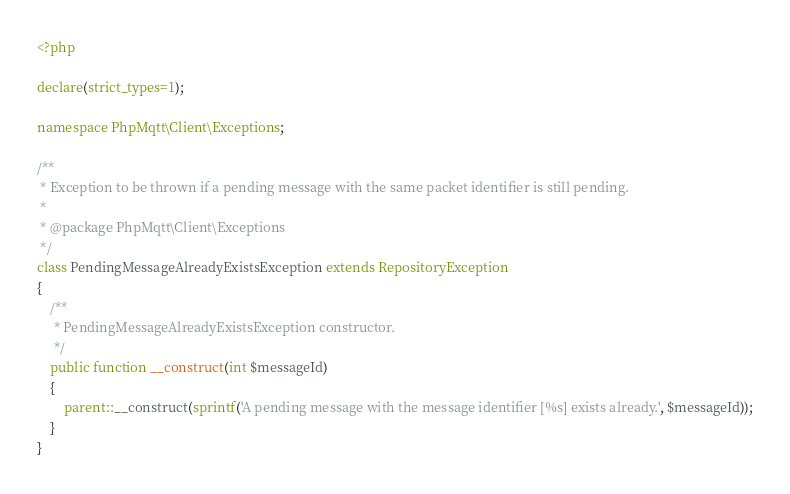Convert code to text. <code><loc_0><loc_0><loc_500><loc_500><_PHP_><?php

declare(strict_types=1);

namespace PhpMqtt\Client\Exceptions;

/**
 * Exception to be thrown if a pending message with the same packet identifier is still pending.
 *
 * @package PhpMqtt\Client\Exceptions
 */
class PendingMessageAlreadyExistsException extends RepositoryException
{
    /**
     * PendingMessageAlreadyExistsException constructor.
     */
    public function __construct(int $messageId)
    {
        parent::__construct(sprintf('A pending message with the message identifier [%s] exists already.', $messageId));
    }
}
</code> 